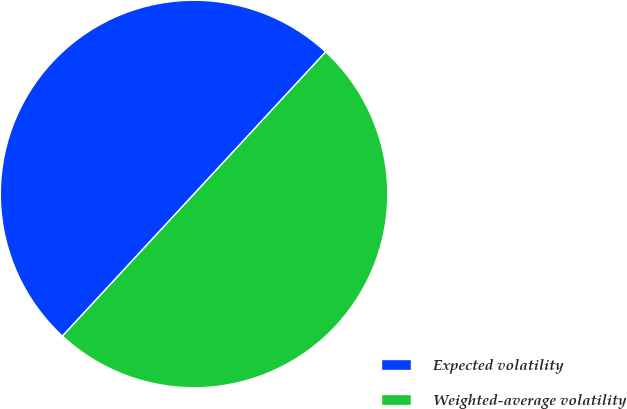Convert chart. <chart><loc_0><loc_0><loc_500><loc_500><pie_chart><fcel>Expected volatility<fcel>Weighted-average volatility<nl><fcel>50.0%<fcel>50.0%<nl></chart> 